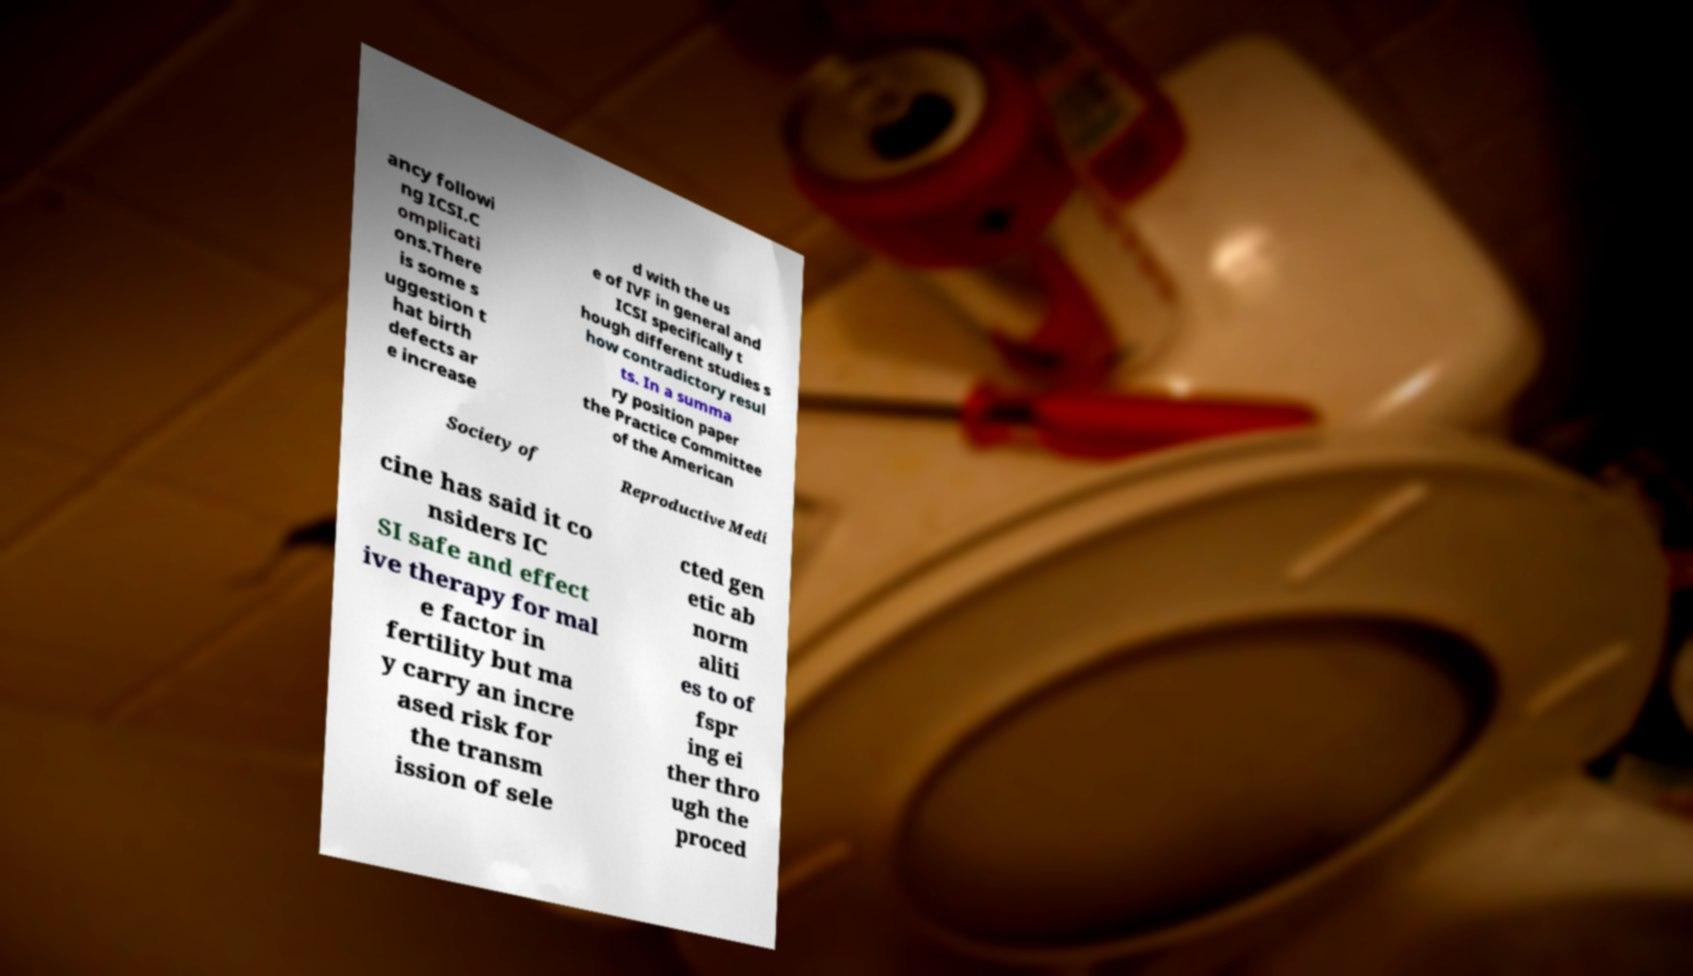I need the written content from this picture converted into text. Can you do that? ancy followi ng ICSI.C omplicati ons.There is some s uggestion t hat birth defects ar e increase d with the us e of IVF in general and ICSI specifically t hough different studies s how contradictory resul ts. In a summa ry position paper the Practice Committee of the American Society of Reproductive Medi cine has said it co nsiders IC SI safe and effect ive therapy for mal e factor in fertility but ma y carry an incre ased risk for the transm ission of sele cted gen etic ab norm aliti es to of fspr ing ei ther thro ugh the proced 